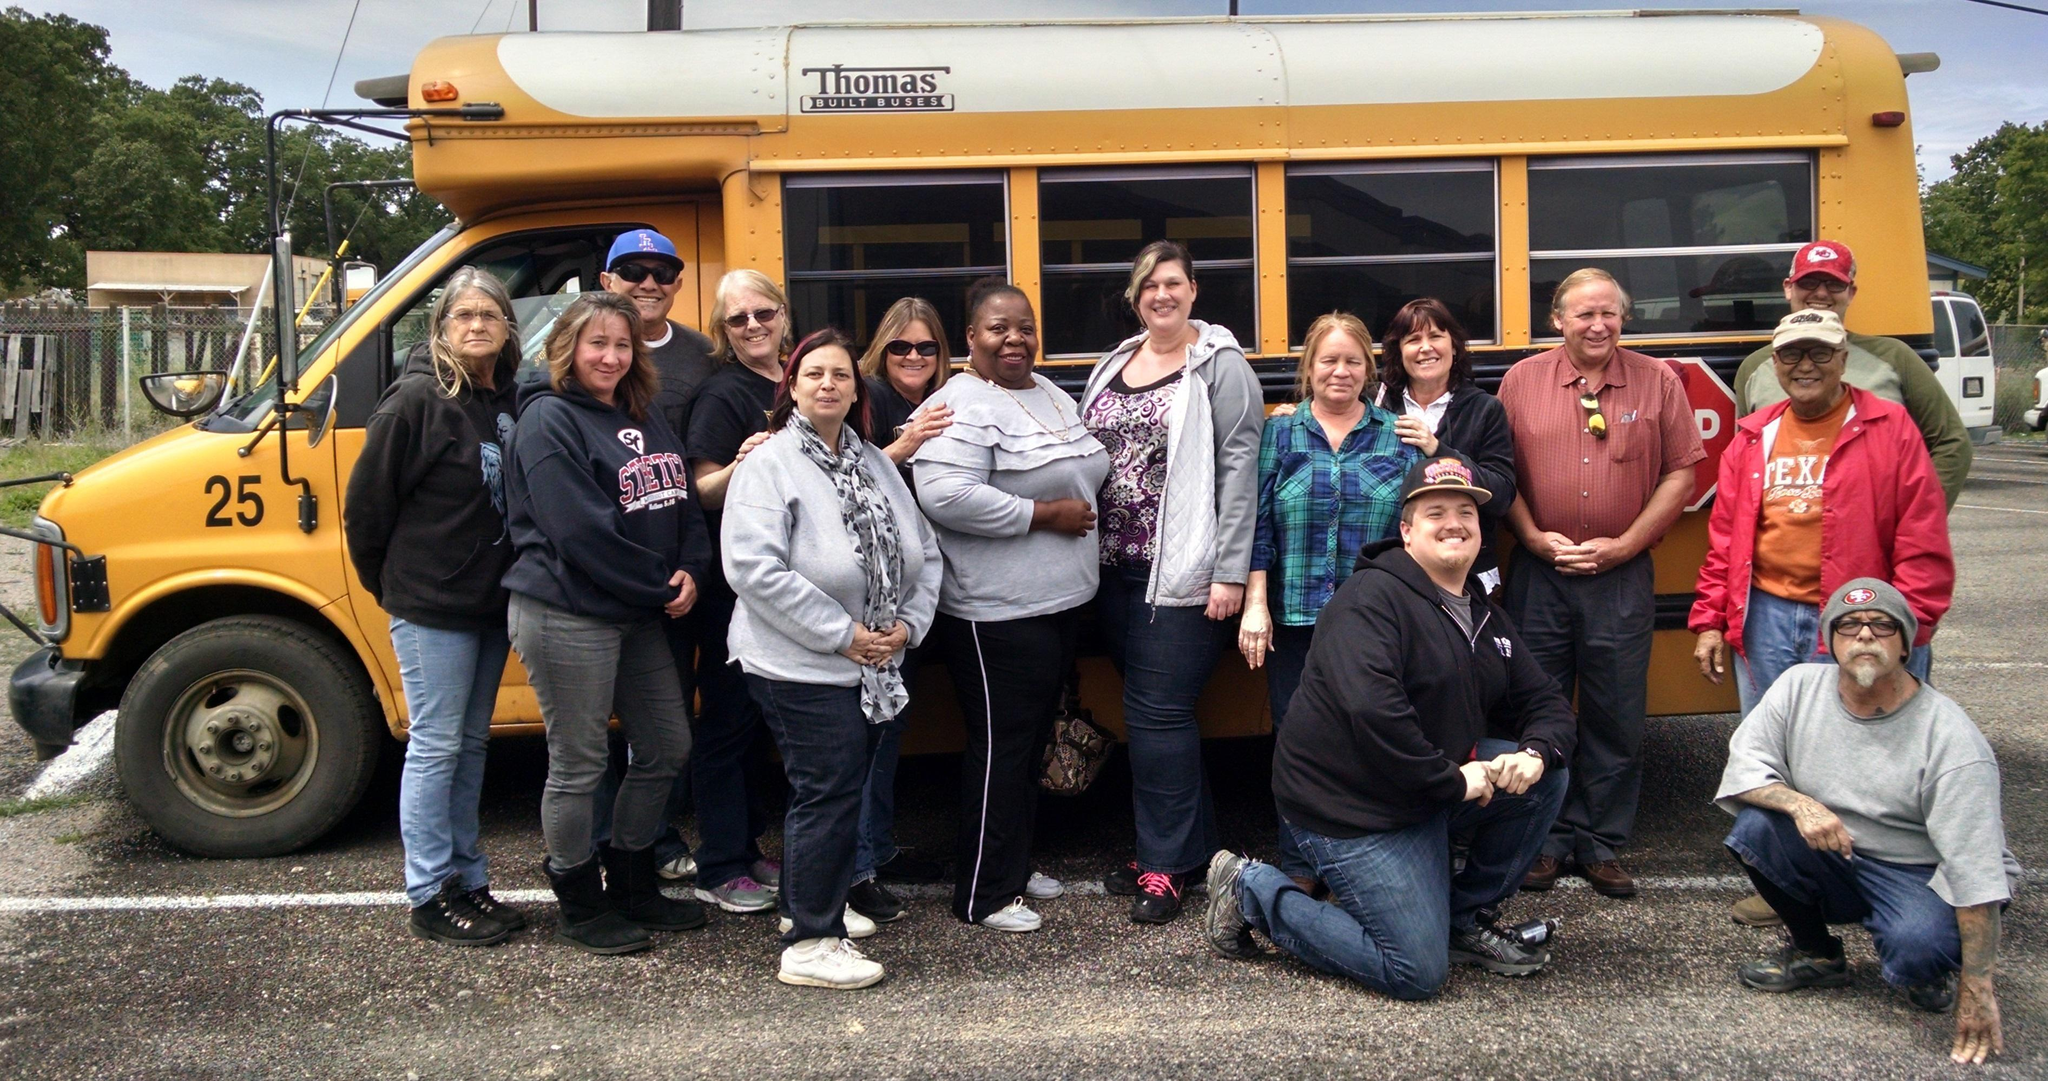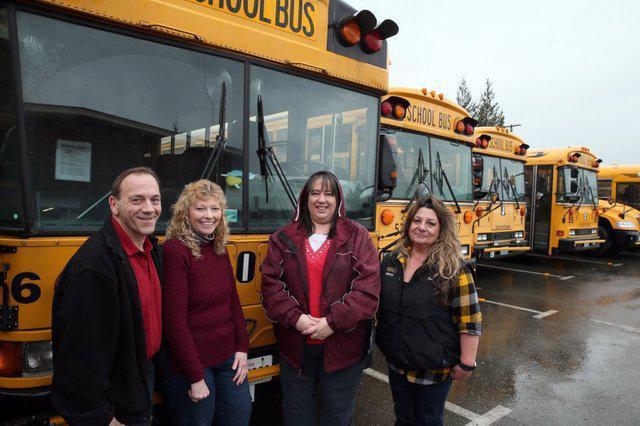The first image is the image on the left, the second image is the image on the right. Considering the images on both sides, is "A severely damaged school bus has a blue tarp hanging down the side." valid? Answer yes or no. No. The first image is the image on the left, the second image is the image on the right. Given the left and right images, does the statement "One image shows a blue tarp covering part of the crumpled side of a yellow bus." hold true? Answer yes or no. No. 